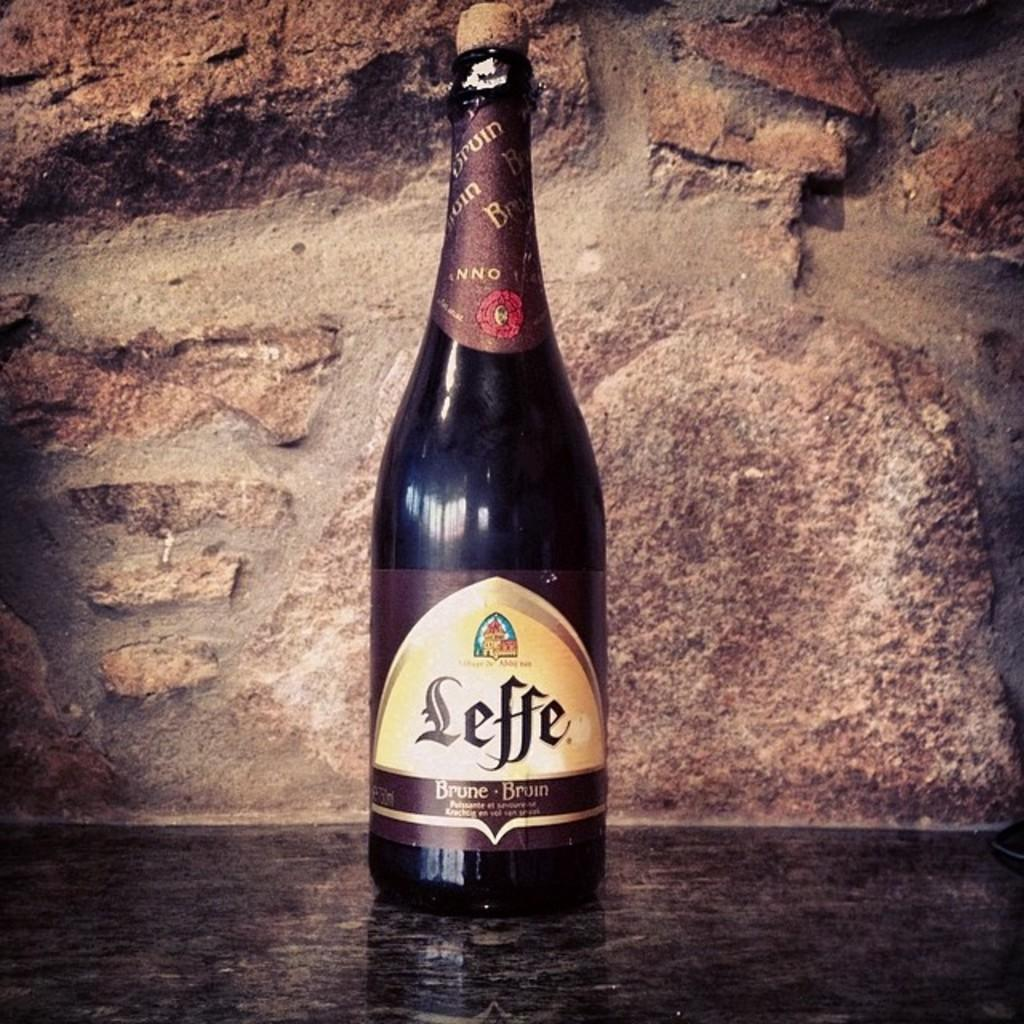<image>
Describe the image concisely. A bottle of Leffe in front of a rock wall. 